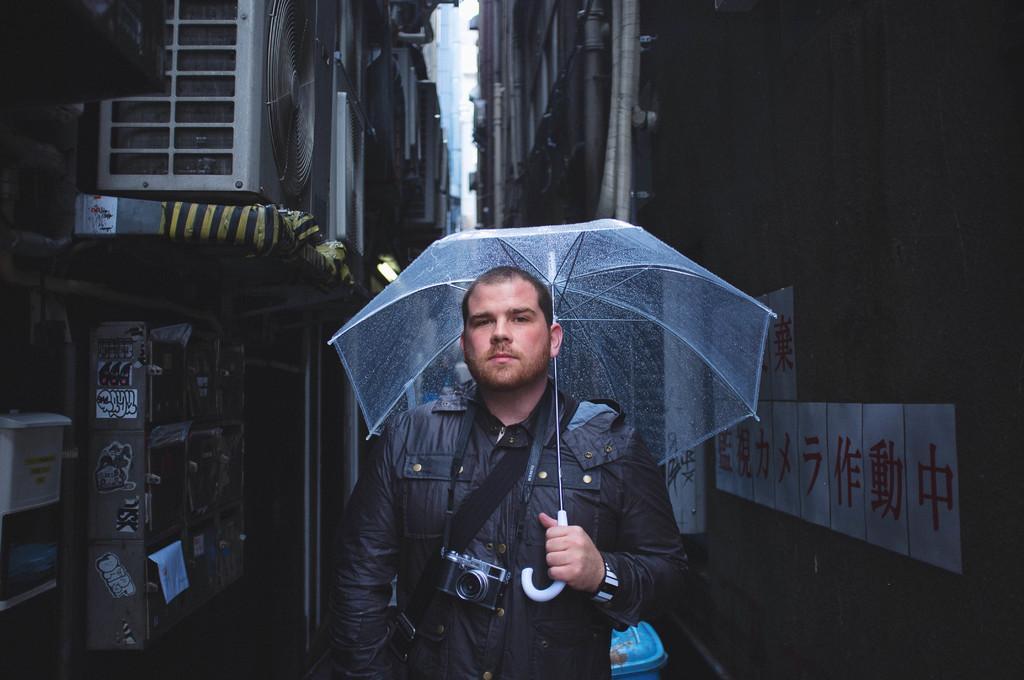How would you summarize this image in a sentence or two? In front of the picture, we see a man in the black jacket is wearing the bag and a camera. He is holding a white umbrella in his hand. Behind him, we see an object in blue color. On either side of the picture, we see the buildings and the posters are pasted on the walls. On the left side, we see the off grid air conditioner. 